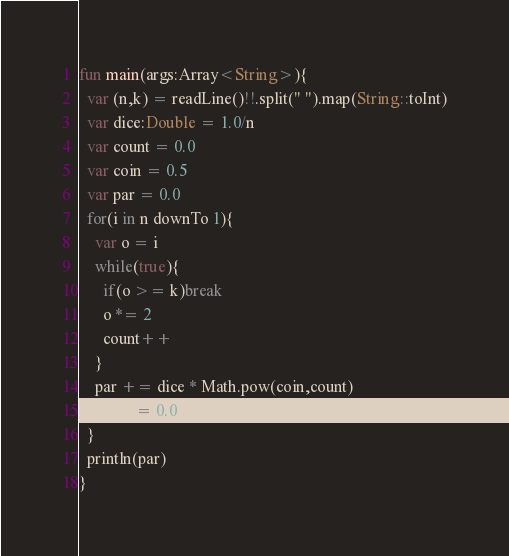Convert code to text. <code><loc_0><loc_0><loc_500><loc_500><_Kotlin_>fun main(args:Array<String>){
  var (n,k) = readLine()!!.split(" ").map(String::toInt)
  var dice:Double = 1.0/n
  var count = 0.0
  var coin = 0.5
  var par = 0.0
  for(i in n downTo 1){
    var o = i
    while(true){
      if(o >= k)break
      o *= 2
      count++
    }
    par += dice * Math.pow(coin,count)
    count = 0.0
  }
  println(par)
}</code> 